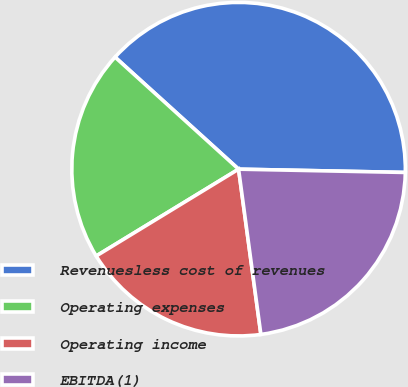Convert chart to OTSL. <chart><loc_0><loc_0><loc_500><loc_500><pie_chart><fcel>Revenuesless cost of revenues<fcel>Operating expenses<fcel>Operating income<fcel>EBITDA(1)<nl><fcel>38.59%<fcel>20.44%<fcel>18.42%<fcel>22.55%<nl></chart> 